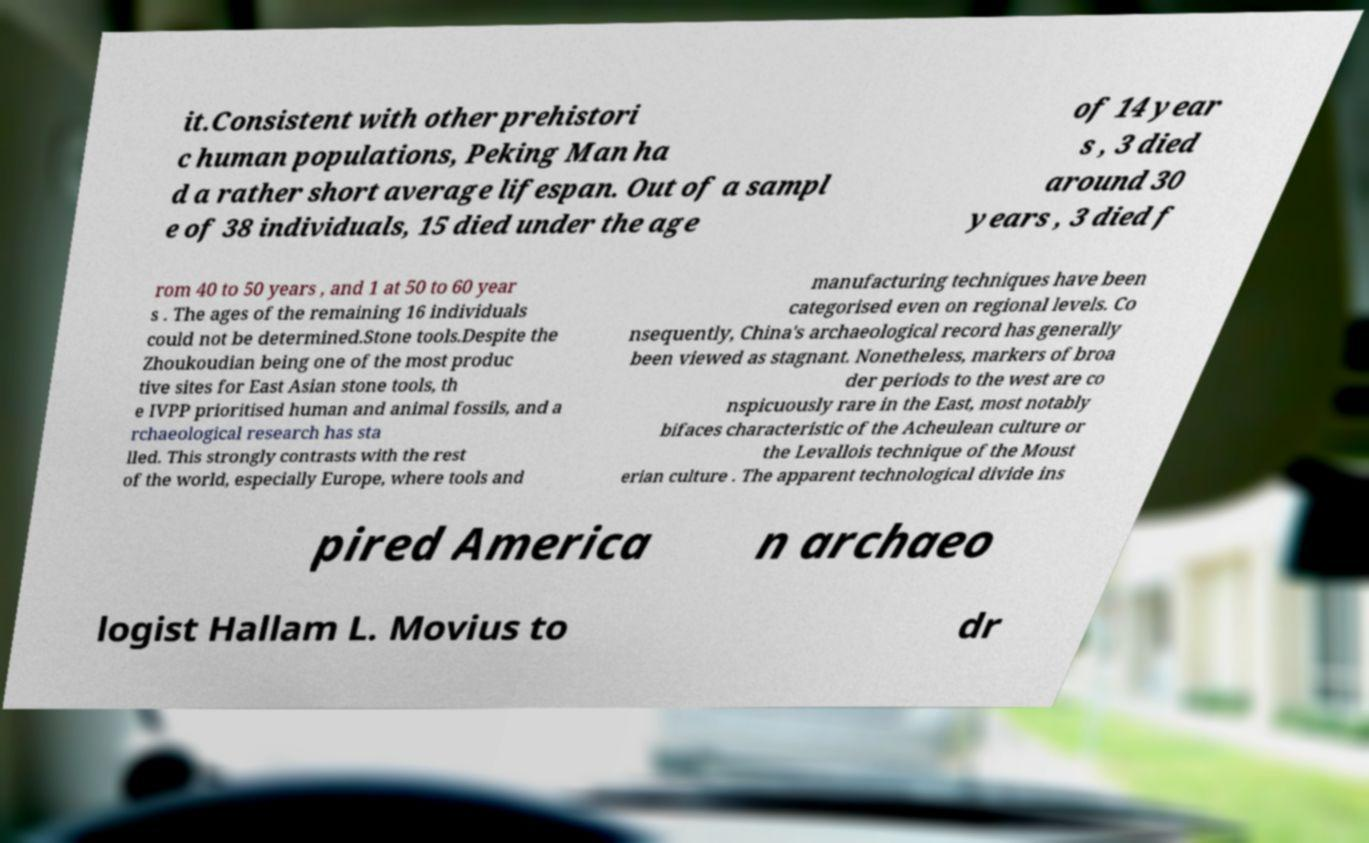Could you assist in decoding the text presented in this image and type it out clearly? it.Consistent with other prehistori c human populations, Peking Man ha d a rather short average lifespan. Out of a sampl e of 38 individuals, 15 died under the age of 14 year s , 3 died around 30 years , 3 died f rom 40 to 50 years , and 1 at 50 to 60 year s . The ages of the remaining 16 individuals could not be determined.Stone tools.Despite the Zhoukoudian being one of the most produc tive sites for East Asian stone tools, th e IVPP prioritised human and animal fossils, and a rchaeological research has sta lled. This strongly contrasts with the rest of the world, especially Europe, where tools and manufacturing techniques have been categorised even on regional levels. Co nsequently, China's archaeological record has generally been viewed as stagnant. Nonetheless, markers of broa der periods to the west are co nspicuously rare in the East, most notably bifaces characteristic of the Acheulean culture or the Levallois technique of the Moust erian culture . The apparent technological divide ins pired America n archaeo logist Hallam L. Movius to dr 